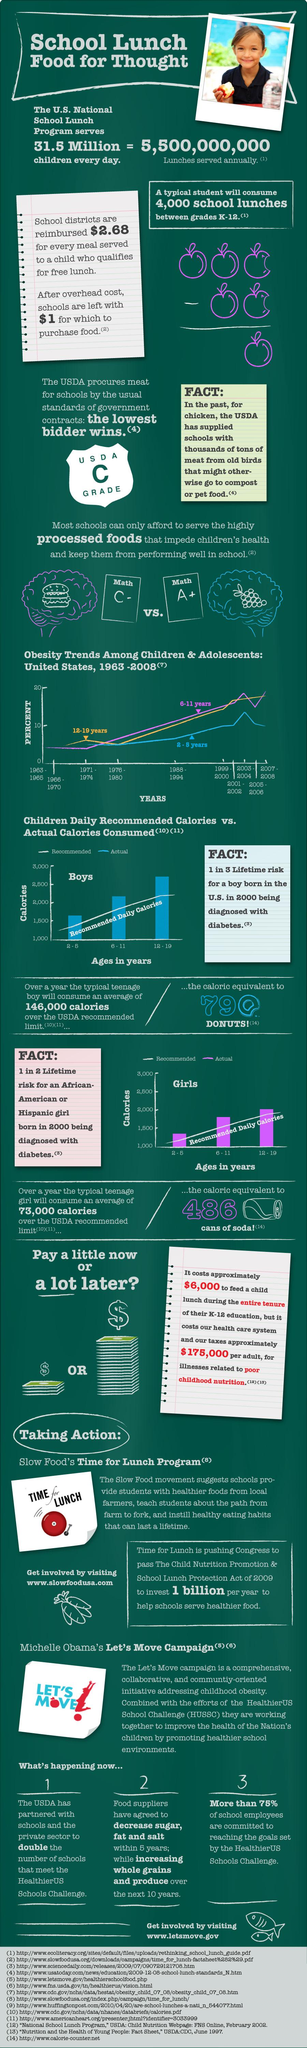Give some essential details in this illustration. According to data, in the age group of girls in the United States between 2 and 5 years old, the actual calories consumed range from 1000 to 1500 calories per day. The actual calorie consumption among boys in the age group of 12 to 19 in the United States falls between 2500 and 3000 calories. According to data, in the age group of boys in the United States between 6 and 11, the actual calories consumed typically range between 2000 and 2500 calories per day. 